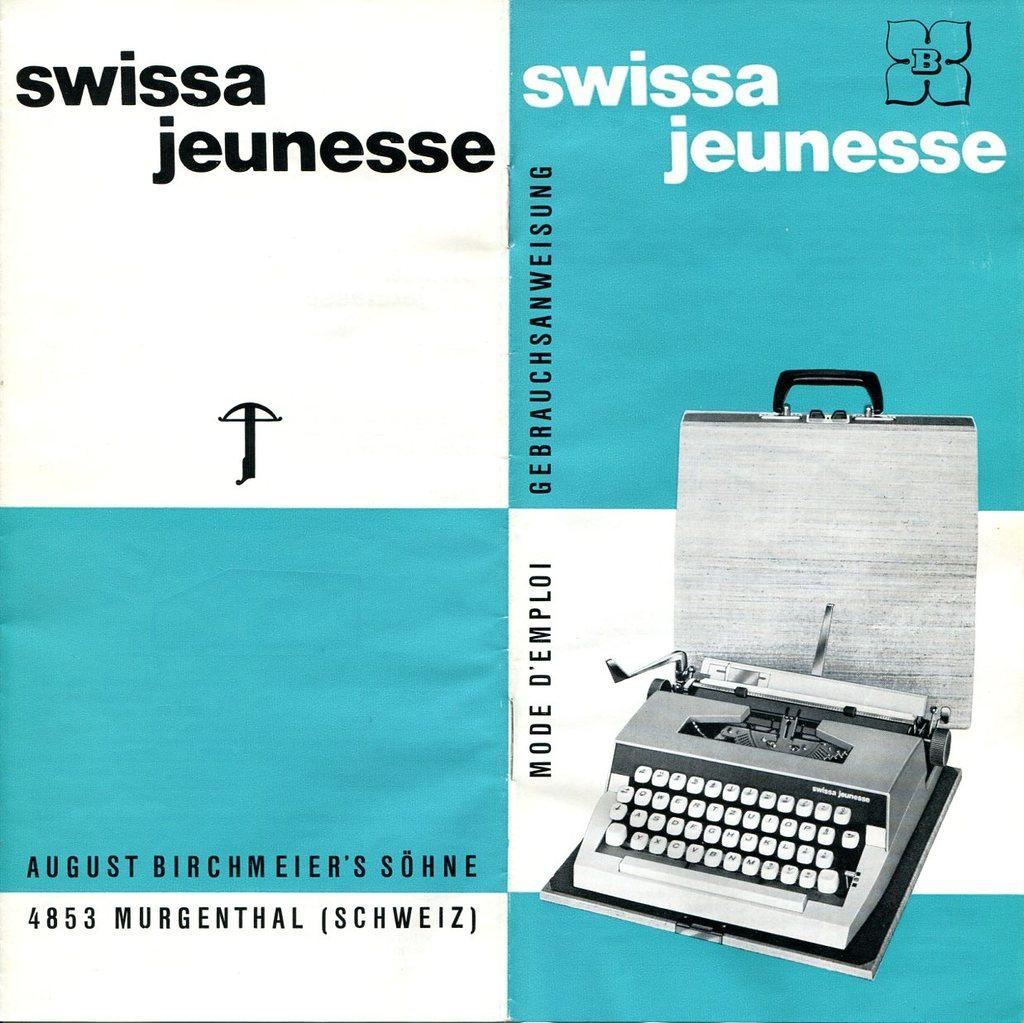<image>
Render a clear and concise summary of the photo. Poster showing a typewriter and the words "Swissa Jeunesse". 